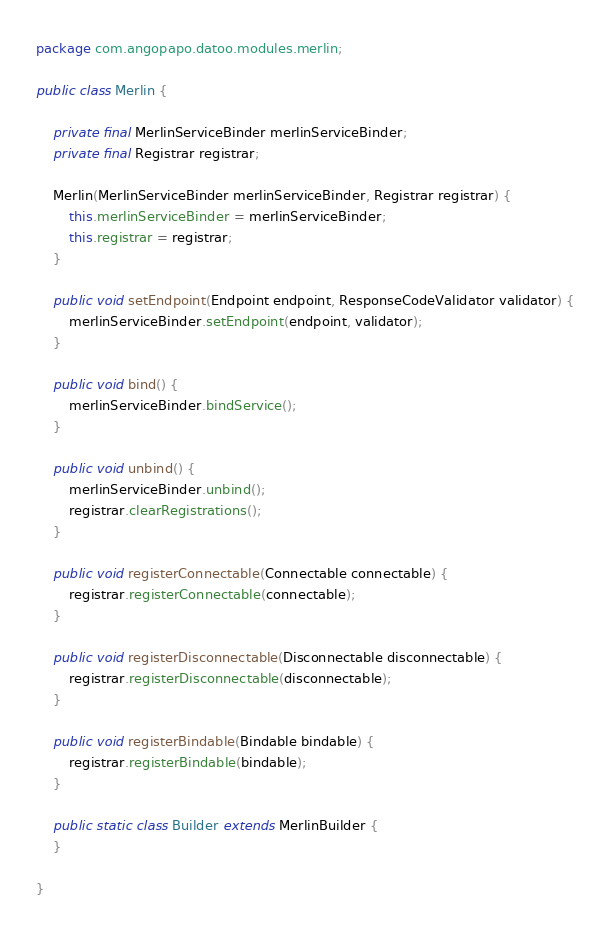<code> <loc_0><loc_0><loc_500><loc_500><_Java_>package com.angopapo.datoo.modules.merlin;

public class Merlin {

    private final MerlinServiceBinder merlinServiceBinder;
    private final Registrar registrar;

    Merlin(MerlinServiceBinder merlinServiceBinder, Registrar registrar) {
        this.merlinServiceBinder = merlinServiceBinder;
        this.registrar = registrar;
    }

    public void setEndpoint(Endpoint endpoint, ResponseCodeValidator validator) {
        merlinServiceBinder.setEndpoint(endpoint, validator);
    }

    public void bind() {
        merlinServiceBinder.bindService();
    }

    public void unbind() {
        merlinServiceBinder.unbind();
        registrar.clearRegistrations();
    }

    public void registerConnectable(Connectable connectable) {
        registrar.registerConnectable(connectable);
    }

    public void registerDisconnectable(Disconnectable disconnectable) {
        registrar.registerDisconnectable(disconnectable);
    }

    public void registerBindable(Bindable bindable) {
        registrar.registerBindable(bindable);
    }

    public static class Builder extends MerlinBuilder {
    }

}
</code> 